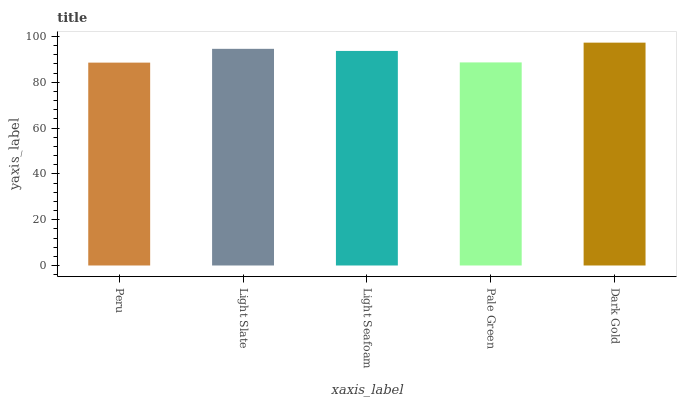Is Peru the minimum?
Answer yes or no. Yes. Is Dark Gold the maximum?
Answer yes or no. Yes. Is Light Slate the minimum?
Answer yes or no. No. Is Light Slate the maximum?
Answer yes or no. No. Is Light Slate greater than Peru?
Answer yes or no. Yes. Is Peru less than Light Slate?
Answer yes or no. Yes. Is Peru greater than Light Slate?
Answer yes or no. No. Is Light Slate less than Peru?
Answer yes or no. No. Is Light Seafoam the high median?
Answer yes or no. Yes. Is Light Seafoam the low median?
Answer yes or no. Yes. Is Pale Green the high median?
Answer yes or no. No. Is Peru the low median?
Answer yes or no. No. 